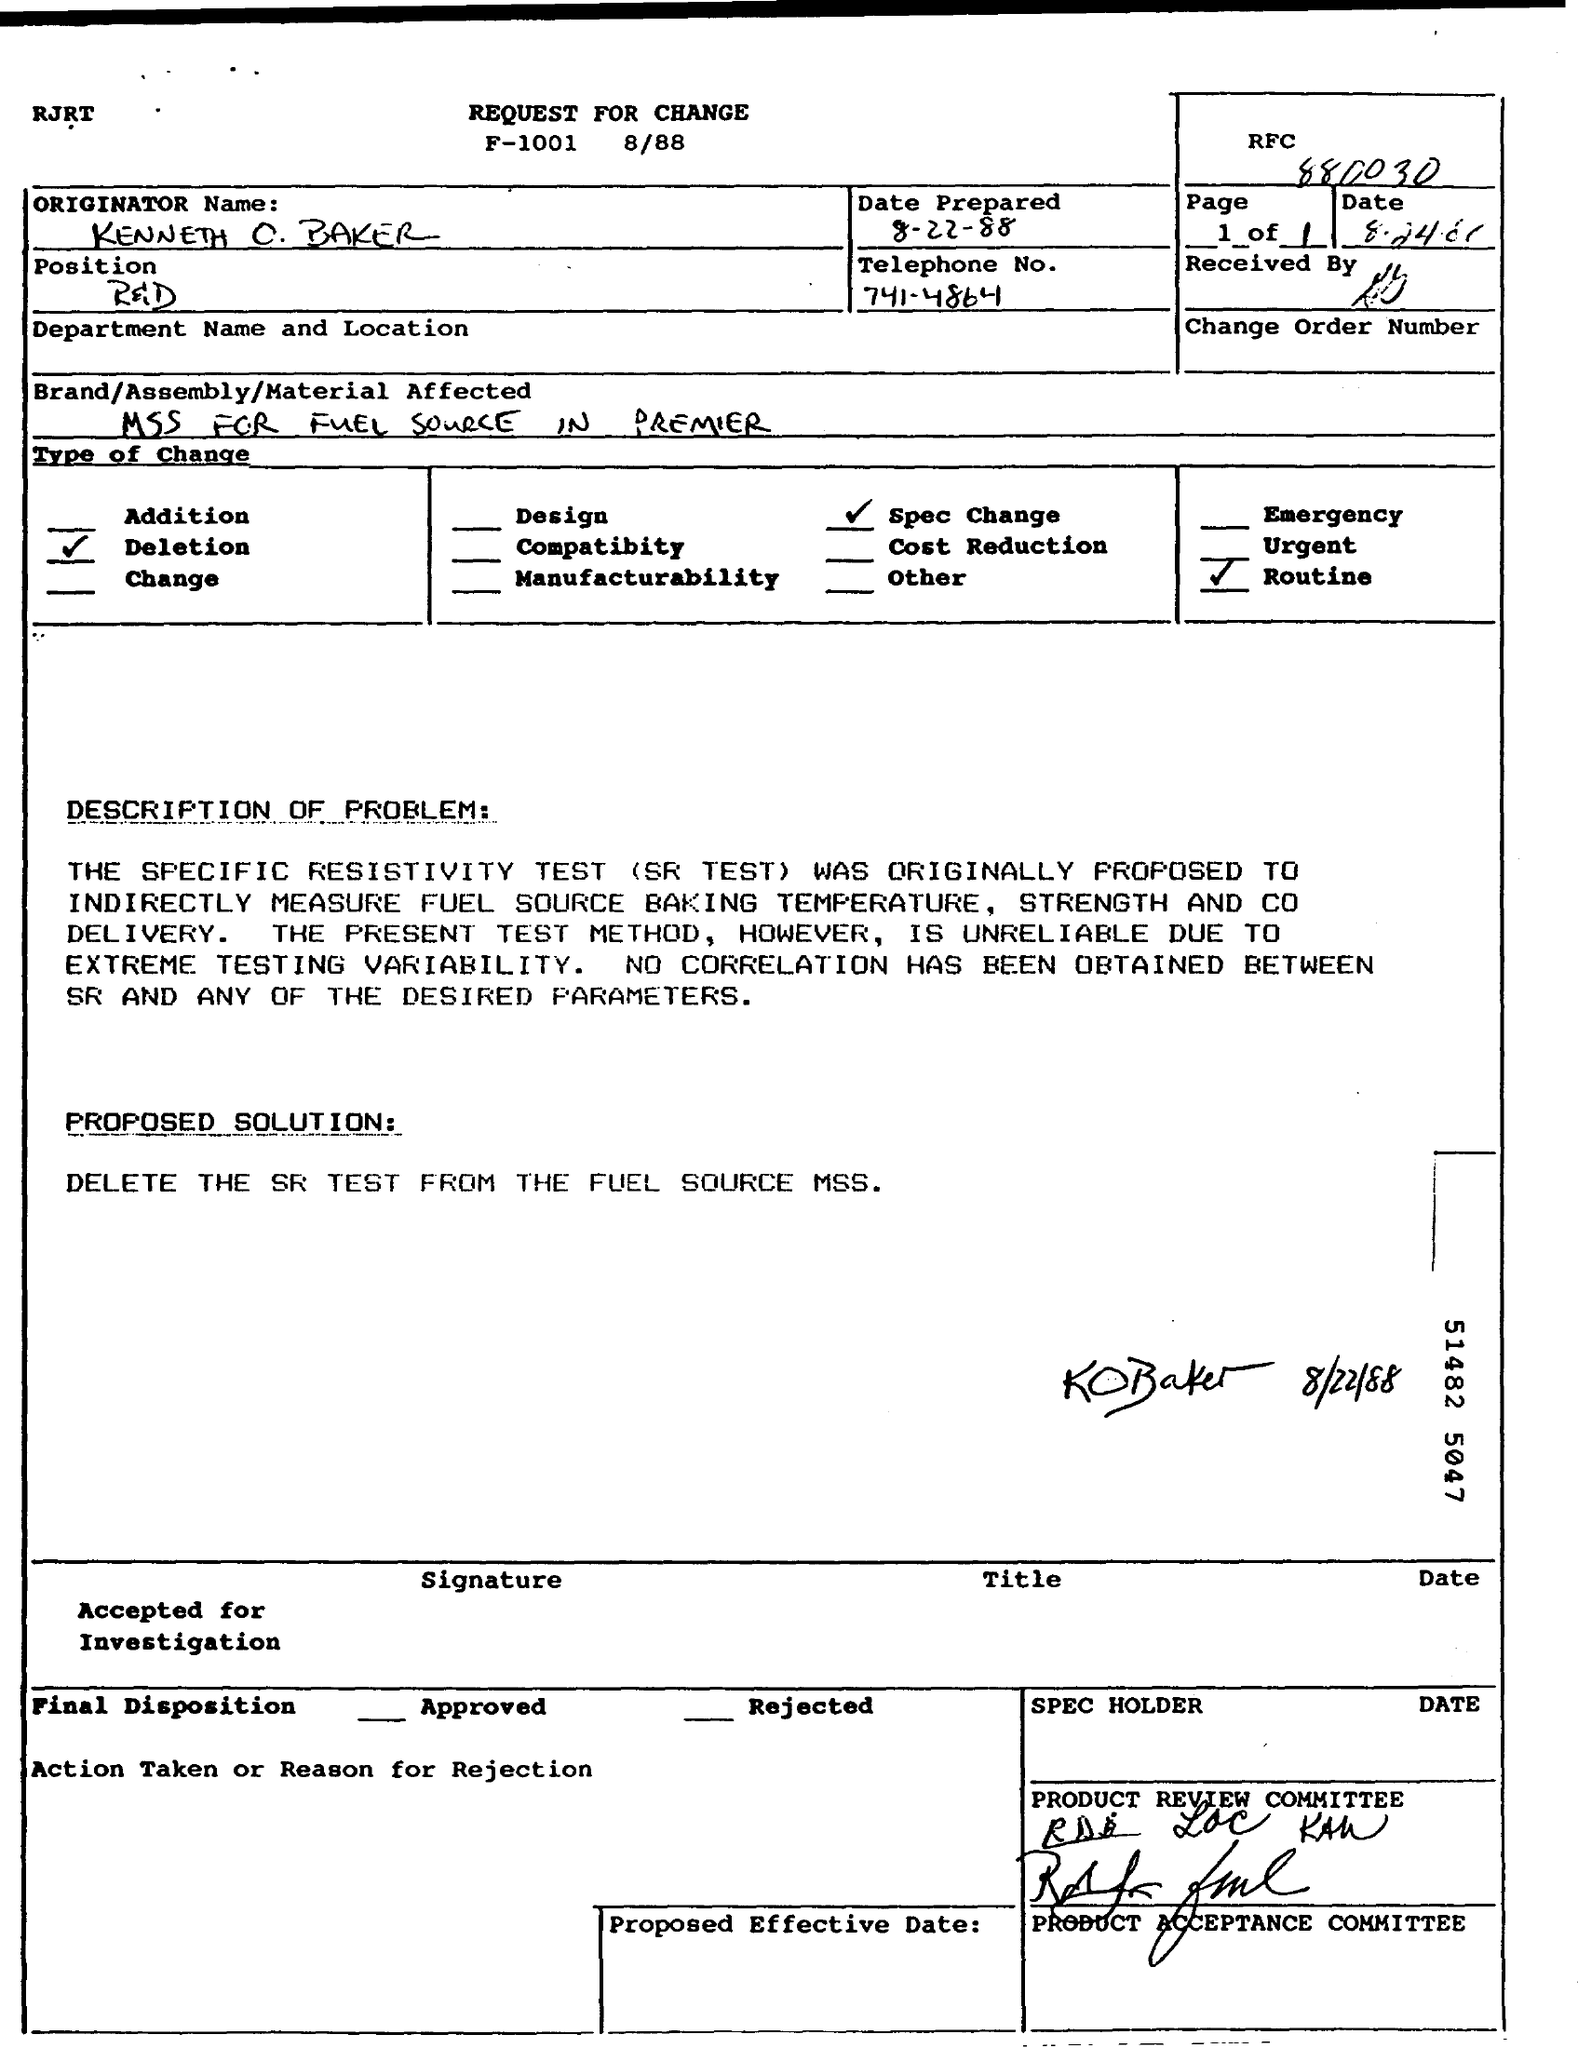What is the Date prepared as per the document?
 8-22-88 